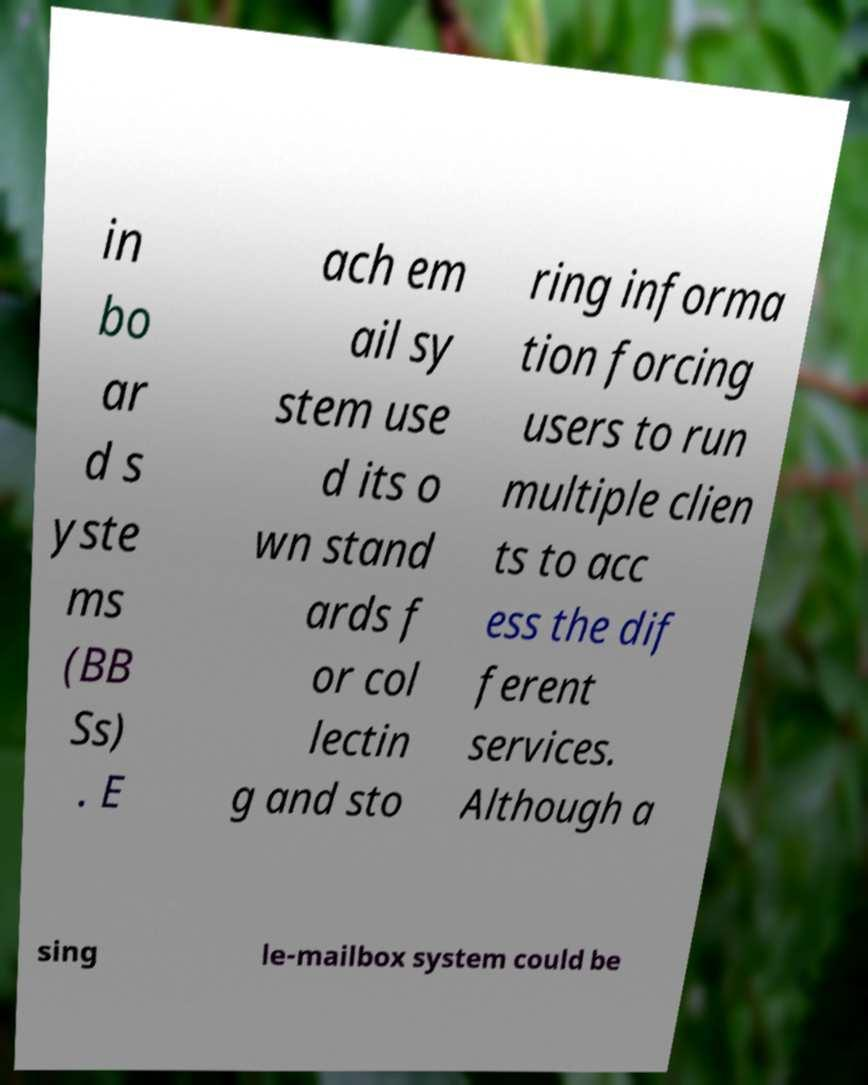Could you extract and type out the text from this image? in bo ar d s yste ms (BB Ss) . E ach em ail sy stem use d its o wn stand ards f or col lectin g and sto ring informa tion forcing users to run multiple clien ts to acc ess the dif ferent services. Although a sing le-mailbox system could be 